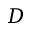<formula> <loc_0><loc_0><loc_500><loc_500>D</formula> 